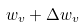<formula> <loc_0><loc_0><loc_500><loc_500>w _ { v } + \Delta w _ { v }</formula> 